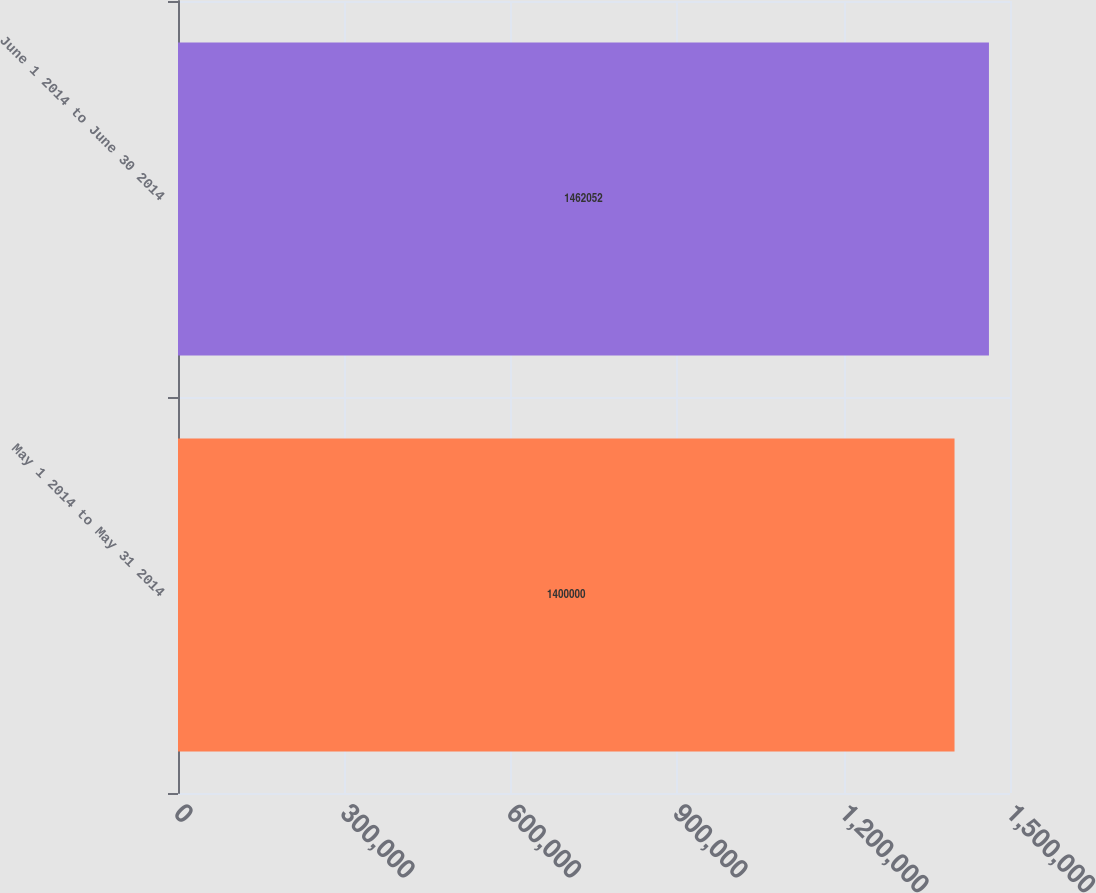<chart> <loc_0><loc_0><loc_500><loc_500><bar_chart><fcel>May 1 2014 to May 31 2014<fcel>June 1 2014 to June 30 2014<nl><fcel>1.4e+06<fcel>1.46205e+06<nl></chart> 